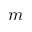<formula> <loc_0><loc_0><loc_500><loc_500>m</formula> 